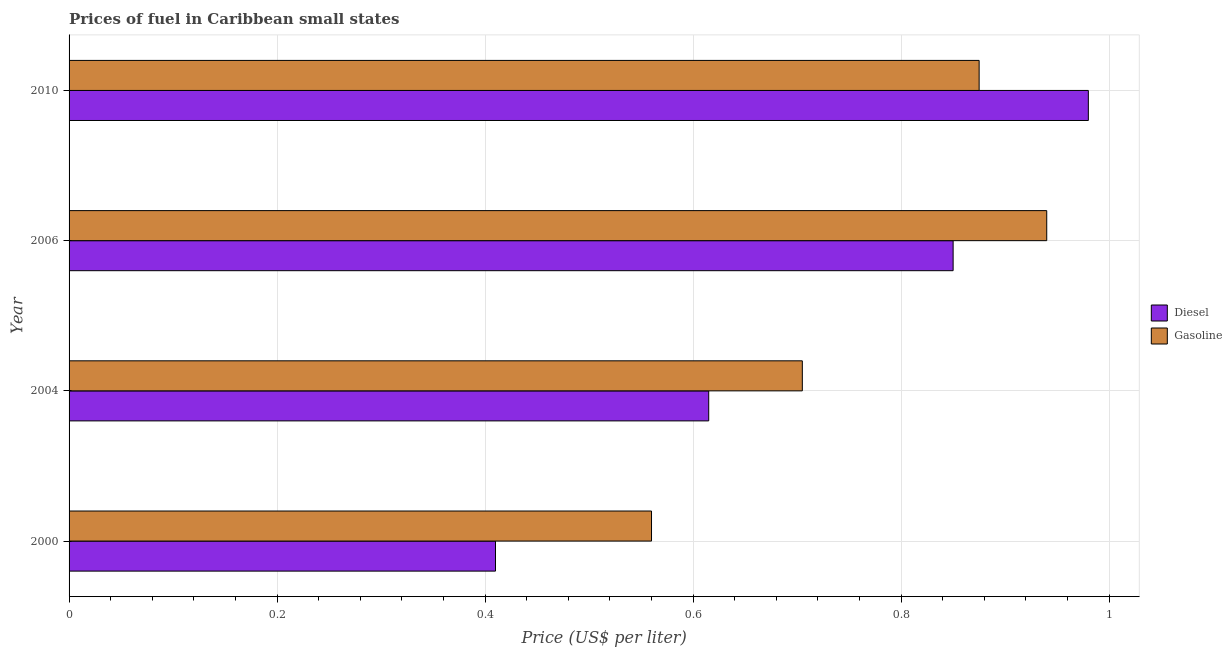How many groups of bars are there?
Keep it short and to the point. 4. Are the number of bars on each tick of the Y-axis equal?
Your answer should be very brief. Yes. How many bars are there on the 1st tick from the top?
Provide a short and direct response. 2. How many bars are there on the 3rd tick from the bottom?
Give a very brief answer. 2. What is the label of the 1st group of bars from the top?
Your answer should be very brief. 2010. In how many cases, is the number of bars for a given year not equal to the number of legend labels?
Provide a short and direct response. 0. Across all years, what is the maximum diesel price?
Offer a very short reply. 0.98. Across all years, what is the minimum diesel price?
Your answer should be very brief. 0.41. In which year was the diesel price minimum?
Give a very brief answer. 2000. What is the total gasoline price in the graph?
Offer a terse response. 3.08. What is the difference between the diesel price in 2004 and that in 2006?
Keep it short and to the point. -0.23. What is the difference between the gasoline price in 2006 and the diesel price in 2000?
Provide a short and direct response. 0.53. What is the average diesel price per year?
Make the answer very short. 0.71. In the year 2010, what is the difference between the diesel price and gasoline price?
Offer a terse response. 0.1. What is the ratio of the diesel price in 2004 to that in 2006?
Offer a very short reply. 0.72. Is the diesel price in 2004 less than that in 2010?
Your answer should be very brief. Yes. What is the difference between the highest and the second highest gasoline price?
Provide a short and direct response. 0.07. What is the difference between the highest and the lowest gasoline price?
Offer a terse response. 0.38. In how many years, is the gasoline price greater than the average gasoline price taken over all years?
Ensure brevity in your answer.  2. Is the sum of the gasoline price in 2004 and 2006 greater than the maximum diesel price across all years?
Offer a very short reply. Yes. What does the 1st bar from the top in 2004 represents?
Provide a succinct answer. Gasoline. What does the 1st bar from the bottom in 2006 represents?
Ensure brevity in your answer.  Diesel. How many bars are there?
Give a very brief answer. 8. Are all the bars in the graph horizontal?
Offer a very short reply. Yes. Are the values on the major ticks of X-axis written in scientific E-notation?
Give a very brief answer. No. Does the graph contain any zero values?
Provide a succinct answer. No. Where does the legend appear in the graph?
Offer a terse response. Center right. What is the title of the graph?
Provide a succinct answer. Prices of fuel in Caribbean small states. Does "Public funds" appear as one of the legend labels in the graph?
Your answer should be very brief. No. What is the label or title of the X-axis?
Ensure brevity in your answer.  Price (US$ per liter). What is the Price (US$ per liter) in Diesel in 2000?
Provide a short and direct response. 0.41. What is the Price (US$ per liter) of Gasoline in 2000?
Offer a very short reply. 0.56. What is the Price (US$ per liter) of Diesel in 2004?
Provide a succinct answer. 0.61. What is the Price (US$ per liter) of Gasoline in 2004?
Keep it short and to the point. 0.7. What is the Price (US$ per liter) of Diesel in 2006?
Keep it short and to the point. 0.85. Across all years, what is the maximum Price (US$ per liter) in Diesel?
Ensure brevity in your answer.  0.98. Across all years, what is the minimum Price (US$ per liter) of Diesel?
Your answer should be very brief. 0.41. Across all years, what is the minimum Price (US$ per liter) of Gasoline?
Make the answer very short. 0.56. What is the total Price (US$ per liter) in Diesel in the graph?
Give a very brief answer. 2.85. What is the total Price (US$ per liter) in Gasoline in the graph?
Offer a terse response. 3.08. What is the difference between the Price (US$ per liter) in Diesel in 2000 and that in 2004?
Your answer should be compact. -0.2. What is the difference between the Price (US$ per liter) in Gasoline in 2000 and that in 2004?
Your answer should be compact. -0.14. What is the difference between the Price (US$ per liter) of Diesel in 2000 and that in 2006?
Offer a very short reply. -0.44. What is the difference between the Price (US$ per liter) in Gasoline in 2000 and that in 2006?
Give a very brief answer. -0.38. What is the difference between the Price (US$ per liter) in Diesel in 2000 and that in 2010?
Provide a short and direct response. -0.57. What is the difference between the Price (US$ per liter) in Gasoline in 2000 and that in 2010?
Provide a short and direct response. -0.32. What is the difference between the Price (US$ per liter) of Diesel in 2004 and that in 2006?
Give a very brief answer. -0.23. What is the difference between the Price (US$ per liter) in Gasoline in 2004 and that in 2006?
Ensure brevity in your answer.  -0.23. What is the difference between the Price (US$ per liter) in Diesel in 2004 and that in 2010?
Offer a very short reply. -0.36. What is the difference between the Price (US$ per liter) of Gasoline in 2004 and that in 2010?
Keep it short and to the point. -0.17. What is the difference between the Price (US$ per liter) in Diesel in 2006 and that in 2010?
Make the answer very short. -0.13. What is the difference between the Price (US$ per liter) in Gasoline in 2006 and that in 2010?
Make the answer very short. 0.07. What is the difference between the Price (US$ per liter) of Diesel in 2000 and the Price (US$ per liter) of Gasoline in 2004?
Provide a succinct answer. -0.29. What is the difference between the Price (US$ per liter) of Diesel in 2000 and the Price (US$ per liter) of Gasoline in 2006?
Provide a short and direct response. -0.53. What is the difference between the Price (US$ per liter) of Diesel in 2000 and the Price (US$ per liter) of Gasoline in 2010?
Ensure brevity in your answer.  -0.47. What is the difference between the Price (US$ per liter) of Diesel in 2004 and the Price (US$ per liter) of Gasoline in 2006?
Give a very brief answer. -0.33. What is the difference between the Price (US$ per liter) in Diesel in 2004 and the Price (US$ per liter) in Gasoline in 2010?
Keep it short and to the point. -0.26. What is the difference between the Price (US$ per liter) in Diesel in 2006 and the Price (US$ per liter) in Gasoline in 2010?
Give a very brief answer. -0.03. What is the average Price (US$ per liter) of Diesel per year?
Provide a short and direct response. 0.71. What is the average Price (US$ per liter) in Gasoline per year?
Provide a short and direct response. 0.77. In the year 2004, what is the difference between the Price (US$ per liter) of Diesel and Price (US$ per liter) of Gasoline?
Your answer should be very brief. -0.09. In the year 2006, what is the difference between the Price (US$ per liter) in Diesel and Price (US$ per liter) in Gasoline?
Ensure brevity in your answer.  -0.09. In the year 2010, what is the difference between the Price (US$ per liter) of Diesel and Price (US$ per liter) of Gasoline?
Ensure brevity in your answer.  0.1. What is the ratio of the Price (US$ per liter) of Gasoline in 2000 to that in 2004?
Keep it short and to the point. 0.79. What is the ratio of the Price (US$ per liter) in Diesel in 2000 to that in 2006?
Your answer should be compact. 0.48. What is the ratio of the Price (US$ per liter) of Gasoline in 2000 to that in 2006?
Provide a short and direct response. 0.6. What is the ratio of the Price (US$ per liter) in Diesel in 2000 to that in 2010?
Offer a terse response. 0.42. What is the ratio of the Price (US$ per liter) in Gasoline in 2000 to that in 2010?
Offer a terse response. 0.64. What is the ratio of the Price (US$ per liter) in Diesel in 2004 to that in 2006?
Your response must be concise. 0.72. What is the ratio of the Price (US$ per liter) in Diesel in 2004 to that in 2010?
Keep it short and to the point. 0.63. What is the ratio of the Price (US$ per liter) of Gasoline in 2004 to that in 2010?
Offer a terse response. 0.81. What is the ratio of the Price (US$ per liter) of Diesel in 2006 to that in 2010?
Provide a short and direct response. 0.87. What is the ratio of the Price (US$ per liter) in Gasoline in 2006 to that in 2010?
Your answer should be compact. 1.07. What is the difference between the highest and the second highest Price (US$ per liter) of Diesel?
Provide a succinct answer. 0.13. What is the difference between the highest and the second highest Price (US$ per liter) of Gasoline?
Ensure brevity in your answer.  0.07. What is the difference between the highest and the lowest Price (US$ per liter) in Diesel?
Give a very brief answer. 0.57. What is the difference between the highest and the lowest Price (US$ per liter) of Gasoline?
Your answer should be compact. 0.38. 